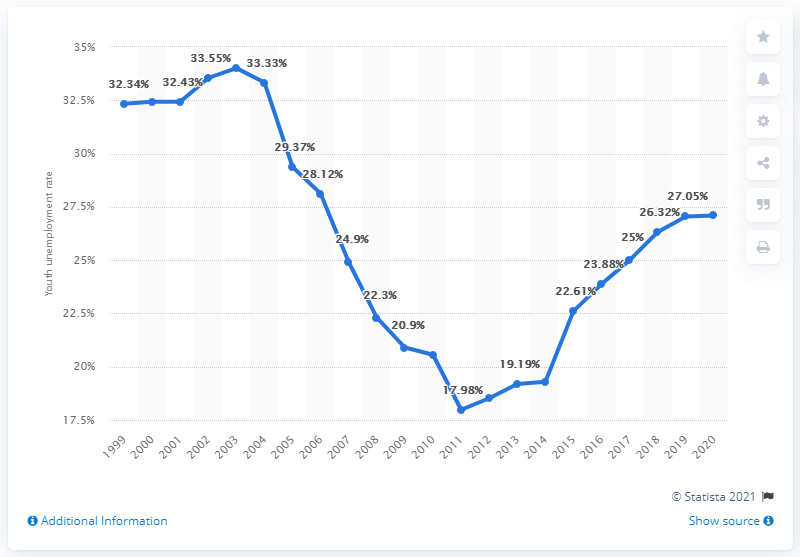Outline some significant characteristics in this image. In 2020, the youth unemployment rate in Uruguay was 27.1%. 